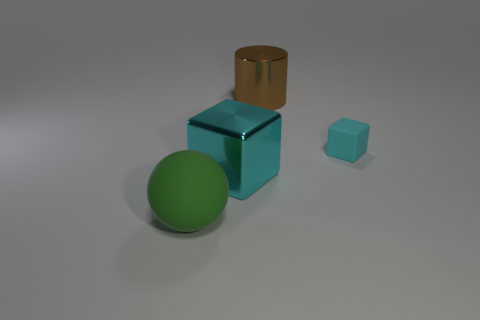Subtract all cylinders. How many objects are left? 3 Add 1 small cyan matte blocks. How many objects exist? 5 Subtract all big cyan metallic things. Subtract all matte cubes. How many objects are left? 2 Add 3 large metallic cylinders. How many large metallic cylinders are left? 4 Add 1 rubber things. How many rubber things exist? 3 Subtract 0 blue cylinders. How many objects are left? 4 Subtract 1 blocks. How many blocks are left? 1 Subtract all brown cubes. Subtract all cyan balls. How many cubes are left? 2 